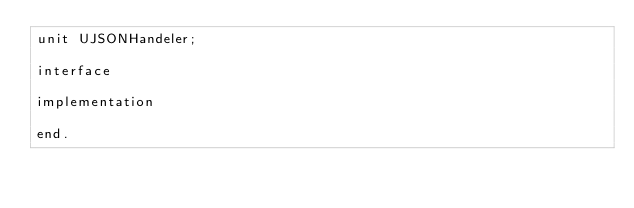Convert code to text. <code><loc_0><loc_0><loc_500><loc_500><_Pascal_>unit UJSONHandeler;

interface

implementation

end.
</code> 